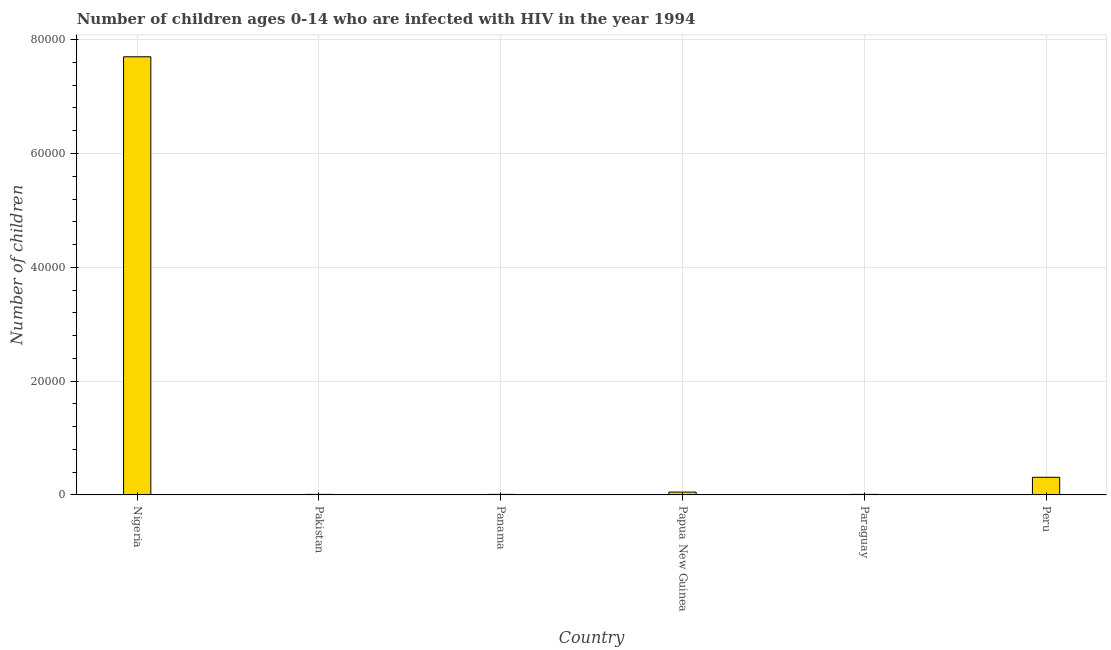Does the graph contain any zero values?
Make the answer very short. No. What is the title of the graph?
Offer a very short reply. Number of children ages 0-14 who are infected with HIV in the year 1994. What is the label or title of the Y-axis?
Make the answer very short. Number of children. Across all countries, what is the maximum number of children living with hiv?
Your answer should be compact. 7.70e+04. In which country was the number of children living with hiv maximum?
Give a very brief answer. Nigeria. In which country was the number of children living with hiv minimum?
Keep it short and to the point. Pakistan. What is the sum of the number of children living with hiv?
Make the answer very short. 8.09e+04. What is the difference between the number of children living with hiv in Nigeria and Papua New Guinea?
Offer a very short reply. 7.65e+04. What is the average number of children living with hiv per country?
Your answer should be compact. 1.35e+04. What is the median number of children living with hiv?
Your answer should be very brief. 300. In how many countries, is the number of children living with hiv greater than 40000 ?
Make the answer very short. 1. What is the ratio of the number of children living with hiv in Pakistan to that in Peru?
Keep it short and to the point. 0.03. Is the number of children living with hiv in Nigeria less than that in Panama?
Your answer should be compact. No. What is the difference between the highest and the second highest number of children living with hiv?
Offer a very short reply. 7.39e+04. Is the sum of the number of children living with hiv in Nigeria and Papua New Guinea greater than the maximum number of children living with hiv across all countries?
Make the answer very short. Yes. What is the difference between the highest and the lowest number of children living with hiv?
Make the answer very short. 7.69e+04. In how many countries, is the number of children living with hiv greater than the average number of children living with hiv taken over all countries?
Offer a very short reply. 1. How many bars are there?
Offer a terse response. 6. Are all the bars in the graph horizontal?
Provide a short and direct response. No. How many countries are there in the graph?
Ensure brevity in your answer.  6. What is the difference between two consecutive major ticks on the Y-axis?
Provide a short and direct response. 2.00e+04. Are the values on the major ticks of Y-axis written in scientific E-notation?
Provide a succinct answer. No. What is the Number of children in Nigeria?
Ensure brevity in your answer.  7.70e+04. What is the Number of children of Panama?
Provide a short and direct response. 100. What is the Number of children of Papua New Guinea?
Ensure brevity in your answer.  500. What is the Number of children of Paraguay?
Offer a terse response. 100. What is the Number of children of Peru?
Ensure brevity in your answer.  3100. What is the difference between the Number of children in Nigeria and Pakistan?
Your answer should be compact. 7.69e+04. What is the difference between the Number of children in Nigeria and Panama?
Give a very brief answer. 7.69e+04. What is the difference between the Number of children in Nigeria and Papua New Guinea?
Provide a short and direct response. 7.65e+04. What is the difference between the Number of children in Nigeria and Paraguay?
Your answer should be very brief. 7.69e+04. What is the difference between the Number of children in Nigeria and Peru?
Provide a short and direct response. 7.39e+04. What is the difference between the Number of children in Pakistan and Papua New Guinea?
Give a very brief answer. -400. What is the difference between the Number of children in Pakistan and Paraguay?
Make the answer very short. 0. What is the difference between the Number of children in Pakistan and Peru?
Offer a terse response. -3000. What is the difference between the Number of children in Panama and Papua New Guinea?
Make the answer very short. -400. What is the difference between the Number of children in Panama and Paraguay?
Keep it short and to the point. 0. What is the difference between the Number of children in Panama and Peru?
Your response must be concise. -3000. What is the difference between the Number of children in Papua New Guinea and Paraguay?
Ensure brevity in your answer.  400. What is the difference between the Number of children in Papua New Guinea and Peru?
Your answer should be compact. -2600. What is the difference between the Number of children in Paraguay and Peru?
Give a very brief answer. -3000. What is the ratio of the Number of children in Nigeria to that in Pakistan?
Keep it short and to the point. 770. What is the ratio of the Number of children in Nigeria to that in Panama?
Ensure brevity in your answer.  770. What is the ratio of the Number of children in Nigeria to that in Papua New Guinea?
Your response must be concise. 154. What is the ratio of the Number of children in Nigeria to that in Paraguay?
Offer a very short reply. 770. What is the ratio of the Number of children in Nigeria to that in Peru?
Ensure brevity in your answer.  24.84. What is the ratio of the Number of children in Pakistan to that in Panama?
Provide a succinct answer. 1. What is the ratio of the Number of children in Pakistan to that in Papua New Guinea?
Offer a terse response. 0.2. What is the ratio of the Number of children in Pakistan to that in Peru?
Your answer should be compact. 0.03. What is the ratio of the Number of children in Panama to that in Papua New Guinea?
Ensure brevity in your answer.  0.2. What is the ratio of the Number of children in Panama to that in Paraguay?
Ensure brevity in your answer.  1. What is the ratio of the Number of children in Panama to that in Peru?
Make the answer very short. 0.03. What is the ratio of the Number of children in Papua New Guinea to that in Paraguay?
Give a very brief answer. 5. What is the ratio of the Number of children in Papua New Guinea to that in Peru?
Give a very brief answer. 0.16. What is the ratio of the Number of children in Paraguay to that in Peru?
Your answer should be compact. 0.03. 